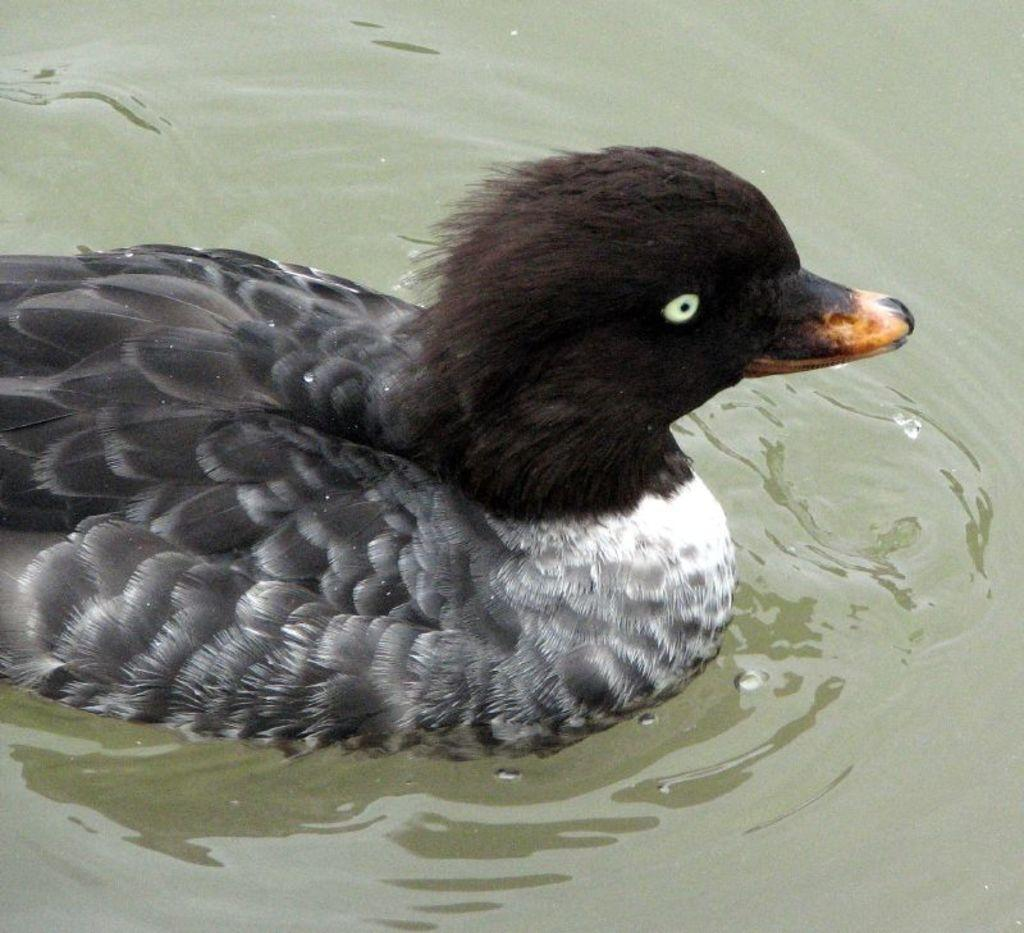What animal is present in the image? There is a duck in the image. Where is the duck located? The duck is in the water. What colors can be seen on the duck? The duck has black and white coloring. What type of fiction is the duck reading in the image? There is no indication in the image that the duck is reading any fiction, as ducks do not read. 